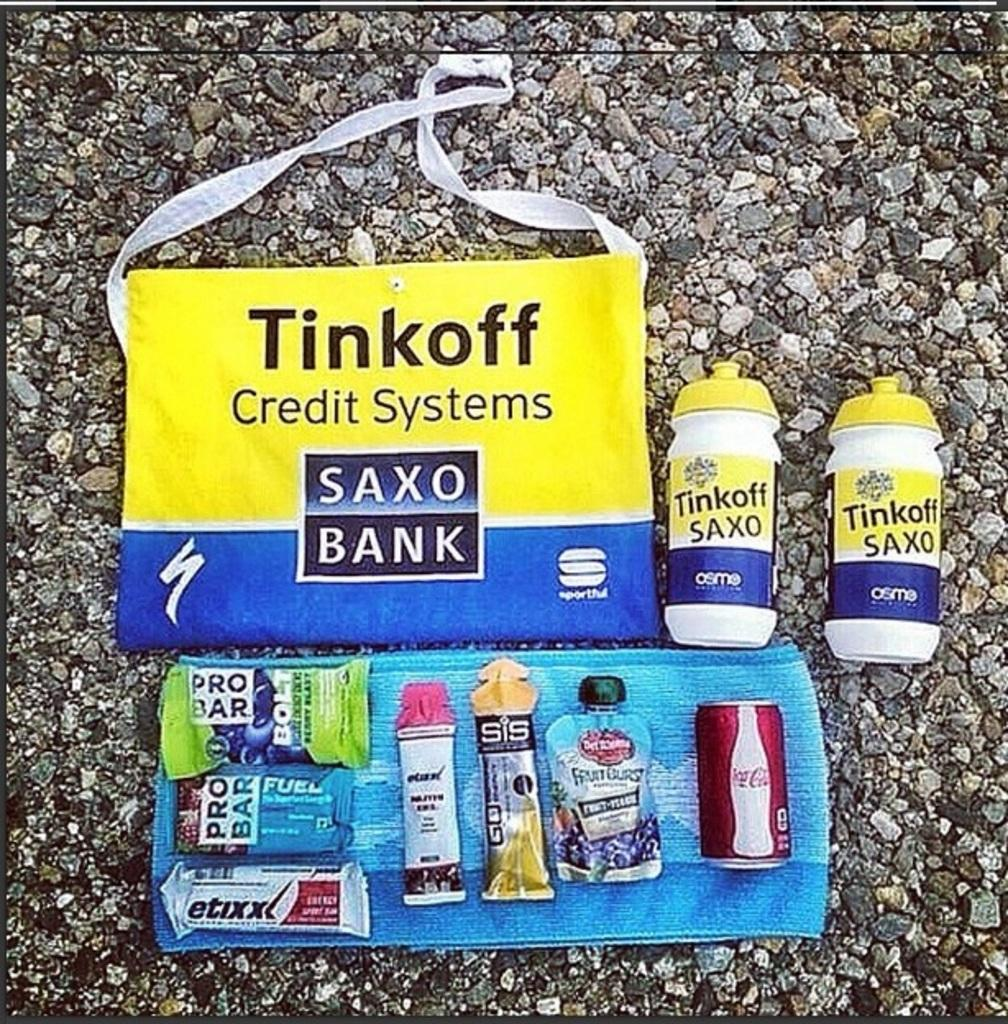<image>
Relay a brief, clear account of the picture shown. A swag bags contents are spread out and include a mini can of Coke. 